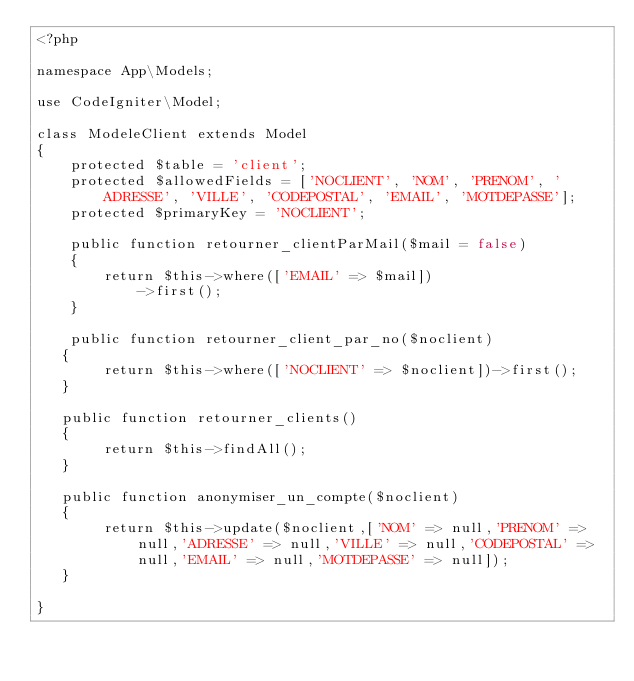<code> <loc_0><loc_0><loc_500><loc_500><_PHP_><?php

namespace App\Models;

use CodeIgniter\Model;

class ModeleClient extends Model
{
    protected $table = 'client';
    protected $allowedFields = ['NOCLIENT', 'NOM', 'PRENOM', 'ADRESSE', 'VILLE', 'CODEPOSTAL', 'EMAIL', 'MOTDEPASSE'];
    protected $primaryKey = 'NOCLIENT';

    public function retourner_clientParMail($mail = false)
    {
        return $this->where(['EMAIL' => $mail])
            ->first();
    }

    public function retourner_client_par_no($noclient)
   {
        return $this->where(['NOCLIENT' => $noclient])->first(); 
   } 

   public function retourner_clients()
   {
        return $this->findAll();
   } 

   public function anonymiser_un_compte($noclient)
   {
        return $this->update($noclient,['NOM' => null,'PRENOM' => null,'ADRESSE' => null,'VILLE' => null,'CODEPOSTAL' => null,'EMAIL' => null,'MOTDEPASSE' => null]);
   }

}
</code> 